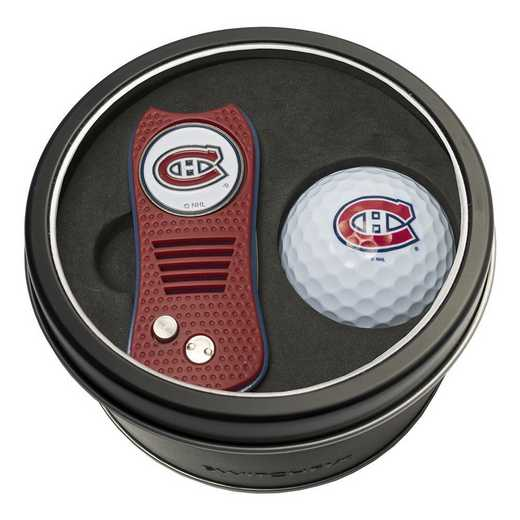Considering the items displayed, what might be the relationship between the golf ball and the divot repair tool, and what could this imply about the intended use or audience for this set? The golf ball and divot repair tool, displayed in the image, are essential components for any golfer, aligning directly with the sport's playing requirements. The inclusion of a logo, representing a specific sports club, heavily implies that these items are specialized merchandise aimed at enthusiasts or members of that organization. This suggests that the set is not just practical for in-game use but also serves as a symbol of affiliation or loyalty to the club. The set could therefore appeal both to active participants who will use the items in their golf sessions and to collectors or supporters of the club who might appreciate the set as memorabilia or a display piece. 